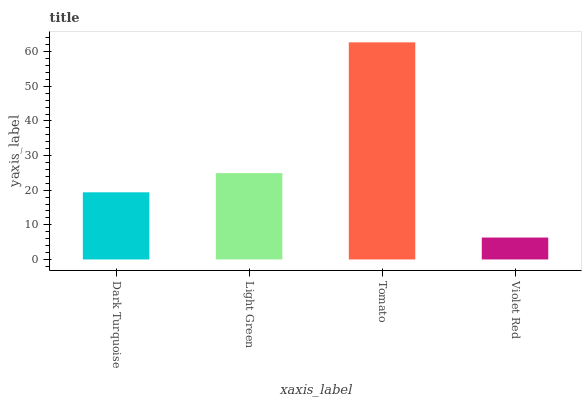Is Violet Red the minimum?
Answer yes or no. Yes. Is Tomato the maximum?
Answer yes or no. Yes. Is Light Green the minimum?
Answer yes or no. No. Is Light Green the maximum?
Answer yes or no. No. Is Light Green greater than Dark Turquoise?
Answer yes or no. Yes. Is Dark Turquoise less than Light Green?
Answer yes or no. Yes. Is Dark Turquoise greater than Light Green?
Answer yes or no. No. Is Light Green less than Dark Turquoise?
Answer yes or no. No. Is Light Green the high median?
Answer yes or no. Yes. Is Dark Turquoise the low median?
Answer yes or no. Yes. Is Dark Turquoise the high median?
Answer yes or no. No. Is Violet Red the low median?
Answer yes or no. No. 